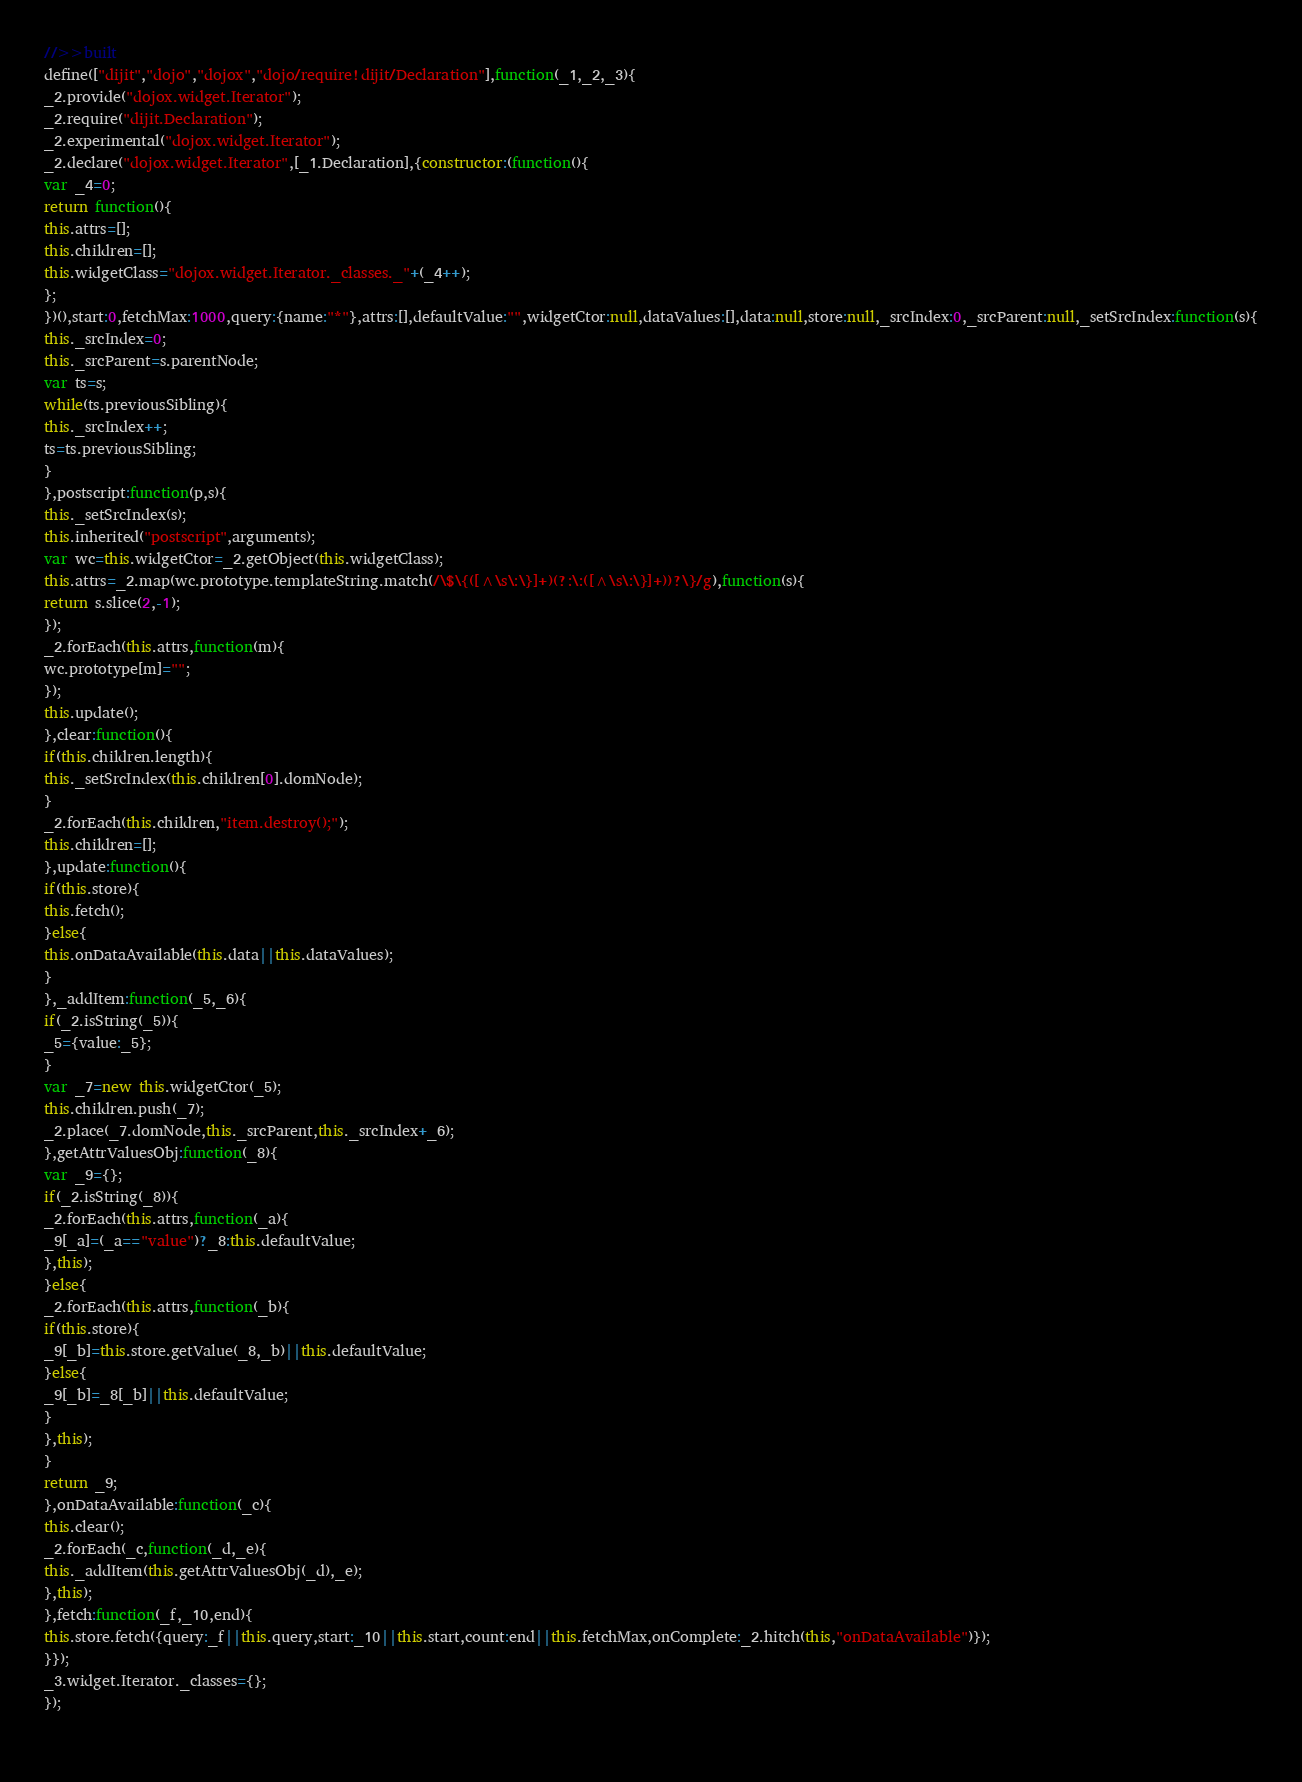Convert code to text. <code><loc_0><loc_0><loc_500><loc_500><_JavaScript_>//>>built
define(["dijit","dojo","dojox","dojo/require!dijit/Declaration"],function(_1,_2,_3){
_2.provide("dojox.widget.Iterator");
_2.require("dijit.Declaration");
_2.experimental("dojox.widget.Iterator");
_2.declare("dojox.widget.Iterator",[_1.Declaration],{constructor:(function(){
var _4=0;
return function(){
this.attrs=[];
this.children=[];
this.widgetClass="dojox.widget.Iterator._classes._"+(_4++);
};
})(),start:0,fetchMax:1000,query:{name:"*"},attrs:[],defaultValue:"",widgetCtor:null,dataValues:[],data:null,store:null,_srcIndex:0,_srcParent:null,_setSrcIndex:function(s){
this._srcIndex=0;
this._srcParent=s.parentNode;
var ts=s;
while(ts.previousSibling){
this._srcIndex++;
ts=ts.previousSibling;
}
},postscript:function(p,s){
this._setSrcIndex(s);
this.inherited("postscript",arguments);
var wc=this.widgetCtor=_2.getObject(this.widgetClass);
this.attrs=_2.map(wc.prototype.templateString.match(/\$\{([^\s\:\}]+)(?:\:([^\s\:\}]+))?\}/g),function(s){
return s.slice(2,-1);
});
_2.forEach(this.attrs,function(m){
wc.prototype[m]="";
});
this.update();
},clear:function(){
if(this.children.length){
this._setSrcIndex(this.children[0].domNode);
}
_2.forEach(this.children,"item.destroy();");
this.children=[];
},update:function(){
if(this.store){
this.fetch();
}else{
this.onDataAvailable(this.data||this.dataValues);
}
},_addItem:function(_5,_6){
if(_2.isString(_5)){
_5={value:_5};
}
var _7=new this.widgetCtor(_5);
this.children.push(_7);
_2.place(_7.domNode,this._srcParent,this._srcIndex+_6);
},getAttrValuesObj:function(_8){
var _9={};
if(_2.isString(_8)){
_2.forEach(this.attrs,function(_a){
_9[_a]=(_a=="value")?_8:this.defaultValue;
},this);
}else{
_2.forEach(this.attrs,function(_b){
if(this.store){
_9[_b]=this.store.getValue(_8,_b)||this.defaultValue;
}else{
_9[_b]=_8[_b]||this.defaultValue;
}
},this);
}
return _9;
},onDataAvailable:function(_c){
this.clear();
_2.forEach(_c,function(_d,_e){
this._addItem(this.getAttrValuesObj(_d),_e);
},this);
},fetch:function(_f,_10,end){
this.store.fetch({query:_f||this.query,start:_10||this.start,count:end||this.fetchMax,onComplete:_2.hitch(this,"onDataAvailable")});
}});
_3.widget.Iterator._classes={};
});
 </code> 